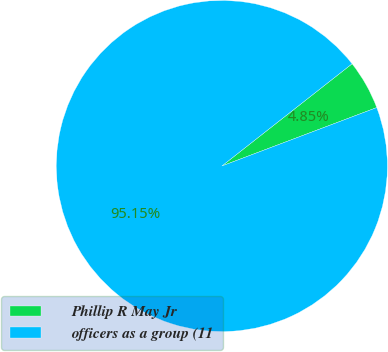Convert chart. <chart><loc_0><loc_0><loc_500><loc_500><pie_chart><fcel>Phillip R May Jr<fcel>officers as a group (11<nl><fcel>4.85%<fcel>95.15%<nl></chart> 